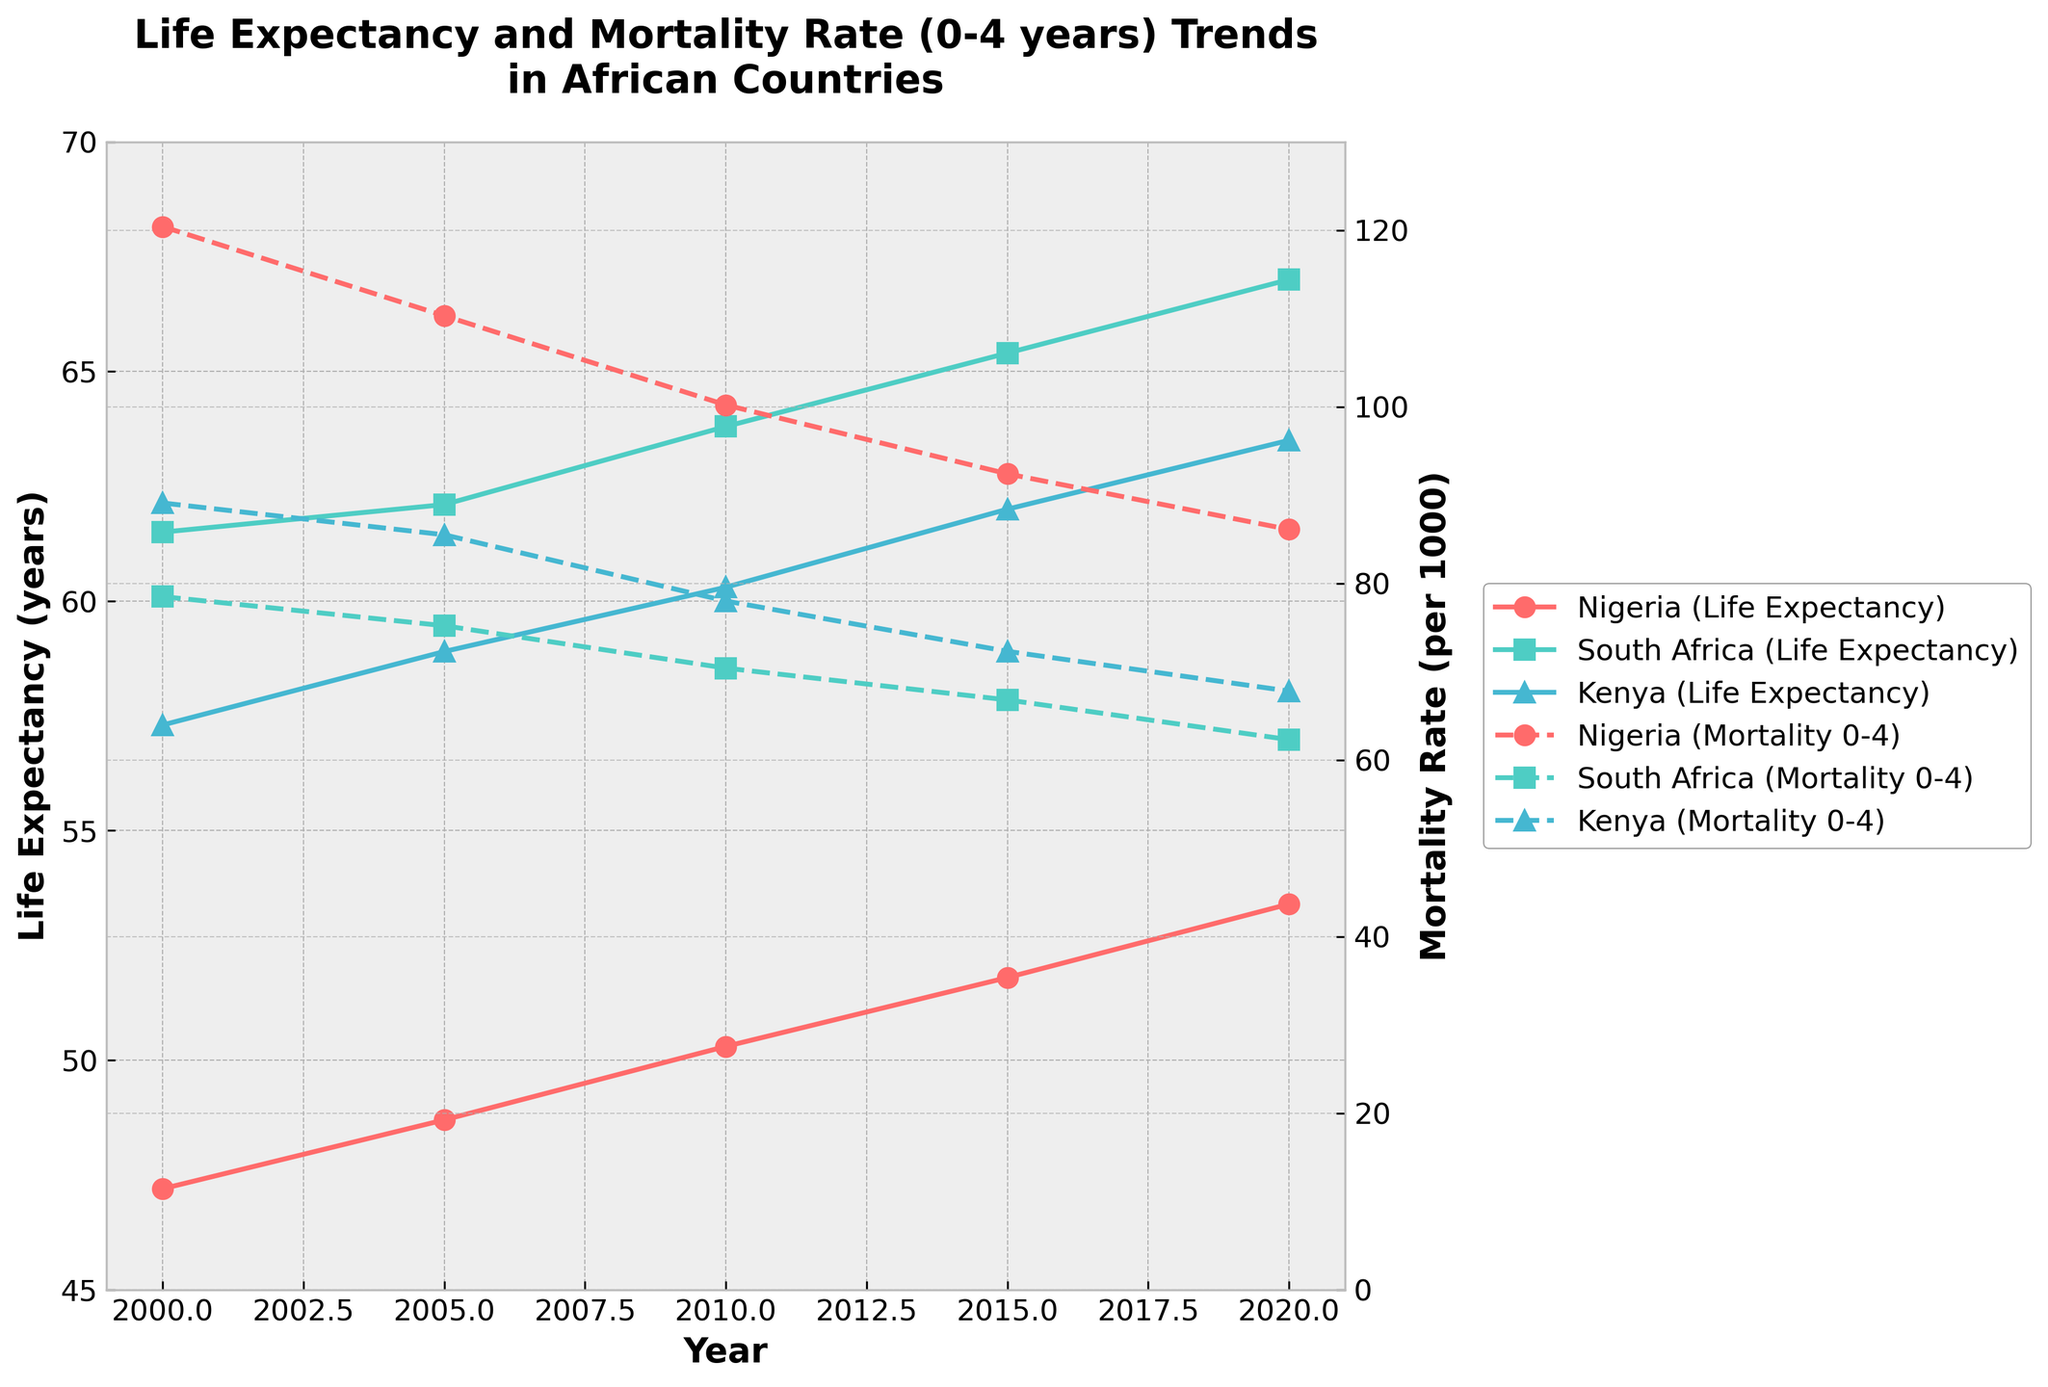How many countries are displayed in the plot? By observing the plot, there are three distinct colors and markers used, each representing a different country.
Answer: 3 Which country has the highest life expectancy in 2020? In the plot, observe the life expectancy trends and locate the highest endpoint for the year 2020 on the respective lines. South Africa has the highest endpoint among the countries in 2020.
Answer: South Africa What is the trend of mortality rate (0-4 years) in Nigeria from 2000 to 2020? Following the dashed line corresponding to Nigeria from left to right, we observe that the line starts high in 2000 and gradually decreases over the years, indicating a downward trend.
Answer: Decreasing Compare the life expectancy trend between South Africa and Kenya. By analyzing the solid lines representing South Africa and Kenya, South Africa's line starts higher and increases more gradually, while Kenya's starts lower but follows a similar increasing trend. South Africa consistently has a higher life expectancy across the years.
Answer: South Africa's life expectancy is consistently higher What is the difference in the mortality rate (0-4 years) between Kenya and Nigeria in 2010? Locate the dashed lines for Kenya and Nigeria at the year 2010 and note the y-axis values. Nigeria’s rate is 100.2 per 1000 and Kenya’s rate is 78.0 per 1000. Calculating the difference: 100.2 - 78.0 = 22.2
Answer: 22.2 per 1000 Which country shows the most significant improvement in life expectancy from 2000 to 2020? Observe each country’s trend line from 2000 to 2020. By examining the increase in life expectancy, South Africa shows the most significant improvement, moving from about 61.5 years to 67.0 years.
Answer: South Africa What is the approximate life expectancy in Kenya in 2005? Find the solid line representing Kenya and identify its value at 2005. The value is near 58.9 years.
Answer: 58.9 years For which country do the mortality rate (0-4 years) and life expectancy trends cross each other? In the plot, distinct visual changes and points of intersection between solid and dashed lines are only present in Nigeria, where the lines cross multiple times over the years.
Answer: Nigeria How does the mortality rate (0-4 years) trend in South Africa from 2000 to 2020 compare to Kenya’s trend over the same period? By comparing the dashed lines for South Africa and Kenya, South Africa shows a consistent decrease more steeply, while Kenya also decreases but less sharply.
Answer: South Africa decreases more sharply 